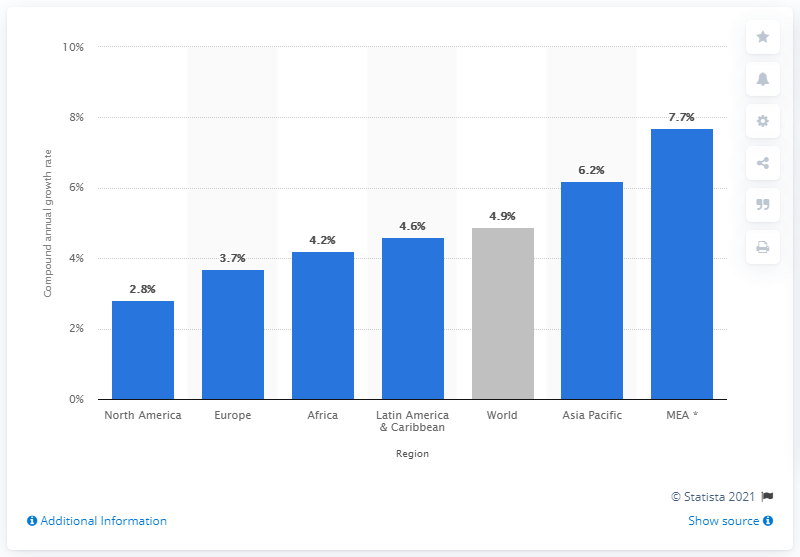Give some essential details in this illustration. According to projections, air passenger traffic in the Asia-Pacific region is expected to grow at an annual rate of 6.2% between 2015 and 2040. 